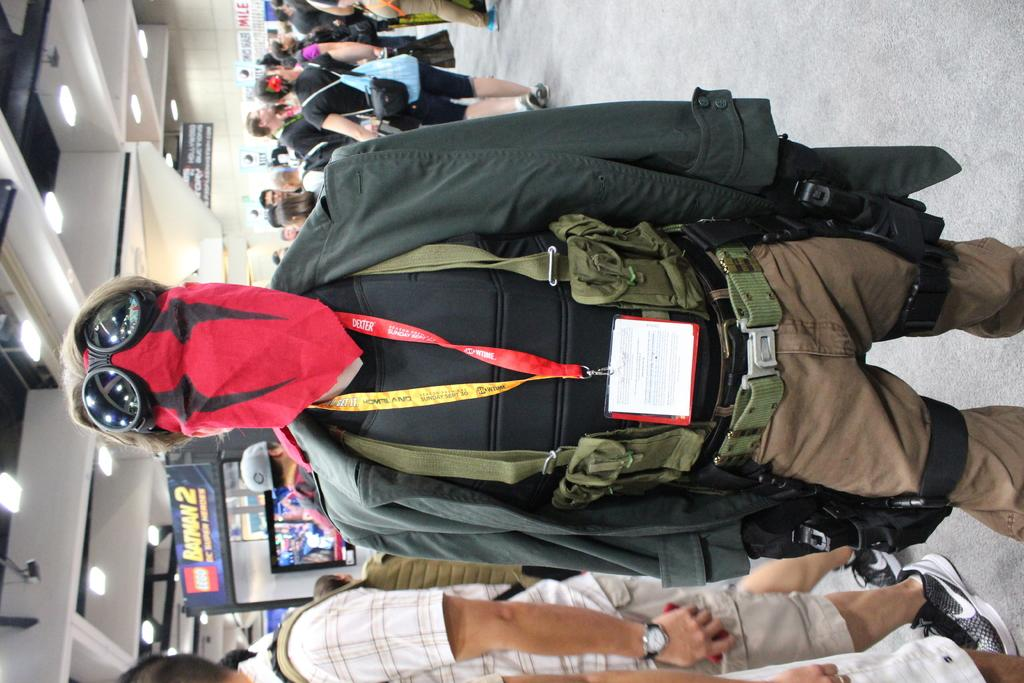<image>
Render a clear and concise summary of the photo. A man wearing a red face mask stands near a Lego Batman 2 display 